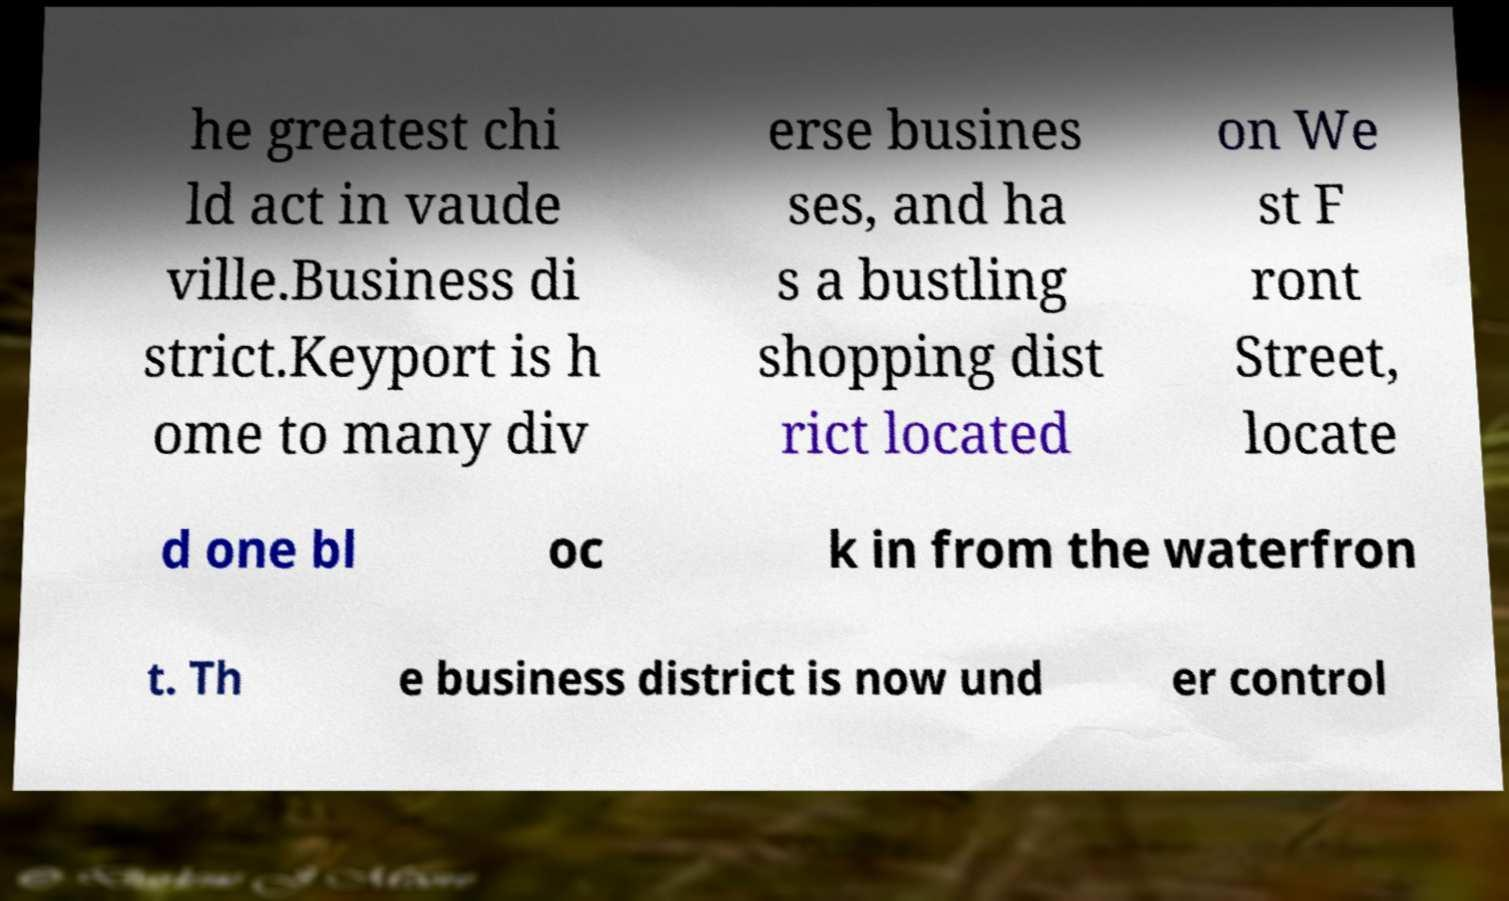Could you extract and type out the text from this image? he greatest chi ld act in vaude ville.Business di strict.Keyport is h ome to many div erse busines ses, and ha s a bustling shopping dist rict located on We st F ront Street, locate d one bl oc k in from the waterfron t. Th e business district is now und er control 